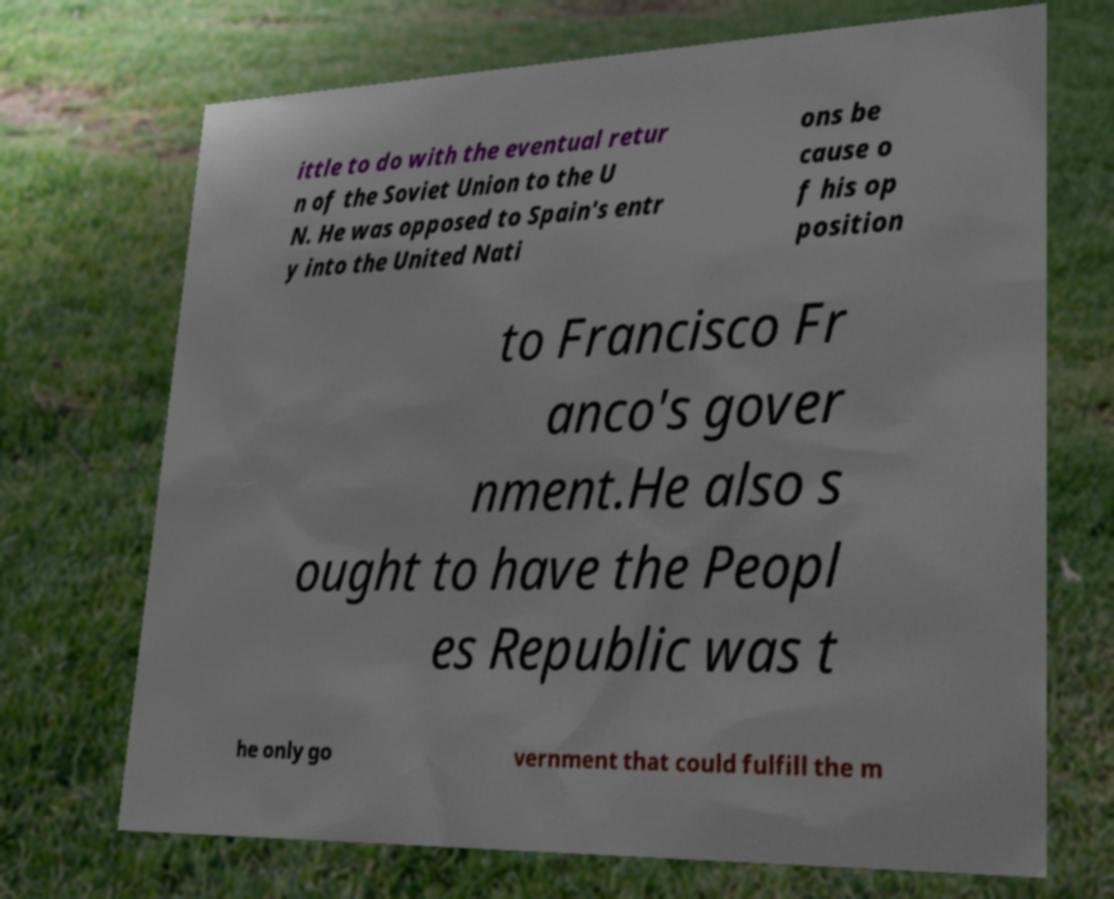Can you read and provide the text displayed in the image?This photo seems to have some interesting text. Can you extract and type it out for me? ittle to do with the eventual retur n of the Soviet Union to the U N. He was opposed to Spain's entr y into the United Nati ons be cause o f his op position to Francisco Fr anco's gover nment.He also s ought to have the Peopl es Republic was t he only go vernment that could fulfill the m 